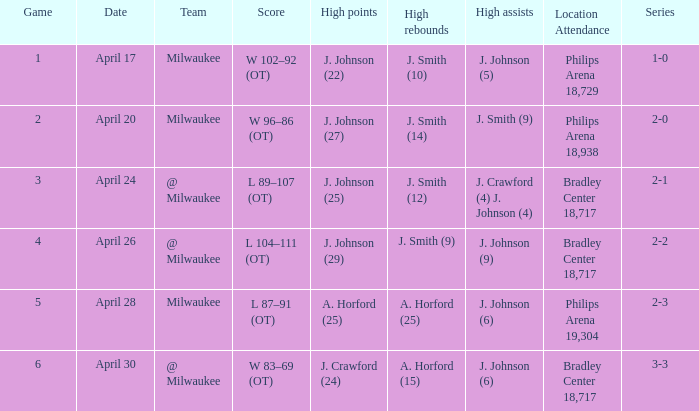In game 2, what was the total count of rebounds? J. Smith (14). 